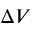<formula> <loc_0><loc_0><loc_500><loc_500>\Delta V</formula> 